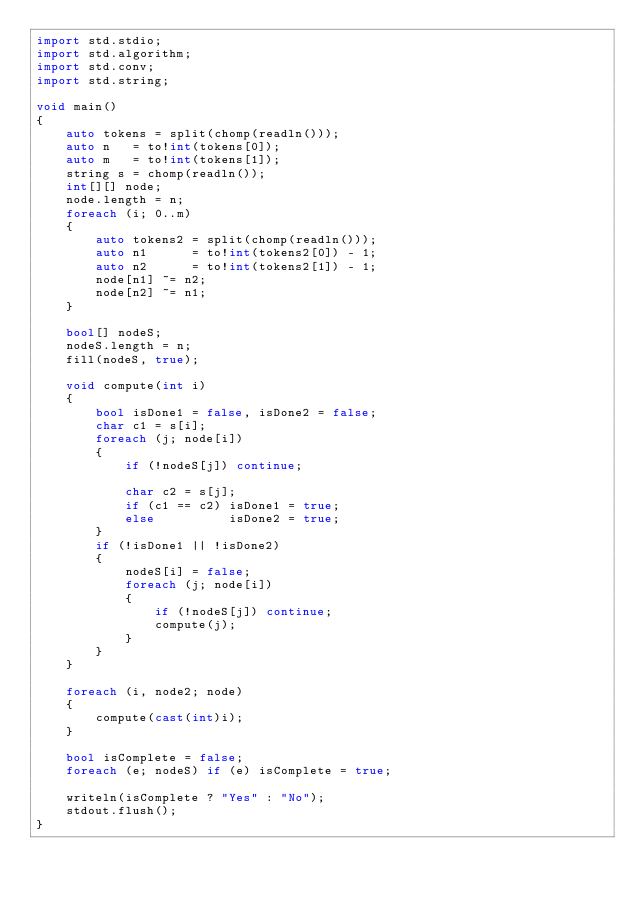<code> <loc_0><loc_0><loc_500><loc_500><_D_>import std.stdio;
import std.algorithm;
import std.conv;
import std.string;

void main()
{
	auto tokens = split(chomp(readln()));
	auto n   = to!int(tokens[0]);
	auto m   = to!int(tokens[1]);
	string s = chomp(readln());
	int[][] node;
	node.length = n;
	foreach (i; 0..m)
	{
		auto tokens2 = split(chomp(readln()));
		auto n1      = to!int(tokens2[0]) - 1;
		auto n2      = to!int(tokens2[1]) - 1;
		node[n1] ~= n2;
		node[n2] ~= n1;
	}

	bool[] nodeS;
	nodeS.length = n;
	fill(nodeS, true);

	void compute(int i)
	{
		bool isDone1 = false, isDone2 = false;
		char c1 = s[i];
		foreach (j; node[i])
		{
			if (!nodeS[j]) continue;

			char c2 = s[j];
			if (c1 == c2) isDone1 = true;
			else		  isDone2 = true;
		}
		if (!isDone1 || !isDone2)
		{
			nodeS[i] = false;
			foreach (j; node[i])
			{
				if (!nodeS[j]) continue;
				compute(j);
			}
		}
	}

	foreach (i, node2; node)
	{
		compute(cast(int)i);
	}

	bool isComplete = false;
	foreach (e; nodeS) if (e) isComplete = true;

	writeln(isComplete ? "Yes" : "No");
	stdout.flush();
}</code> 